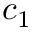<formula> <loc_0><loc_0><loc_500><loc_500>c _ { 1 }</formula> 